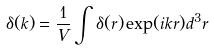Convert formula to latex. <formula><loc_0><loc_0><loc_500><loc_500>\delta ( { k } ) = \frac { 1 } { V } \int \delta ( { r } ) \exp ( i { k r } ) d ^ { 3 } { r }</formula> 